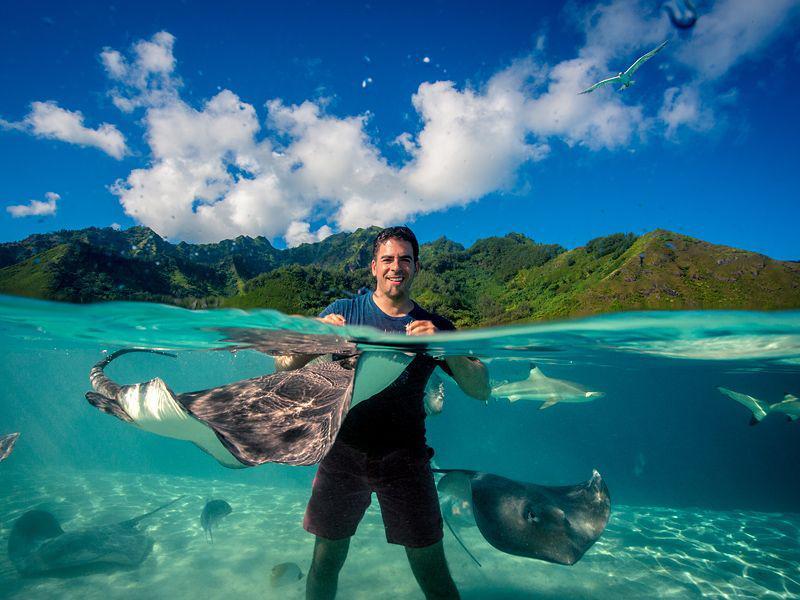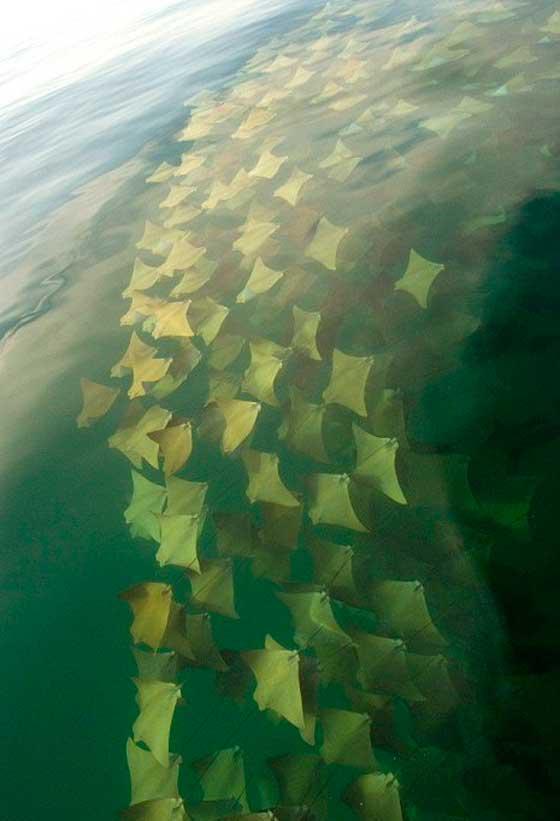The first image is the image on the left, the second image is the image on the right. Assess this claim about the two images: "At least one human is standig in water where stingray are swimming.". Correct or not? Answer yes or no. Yes. The first image is the image on the left, the second image is the image on the right. Considering the images on both sides, is "There is a man, standing among the manta rays." valid? Answer yes or no. Yes. 